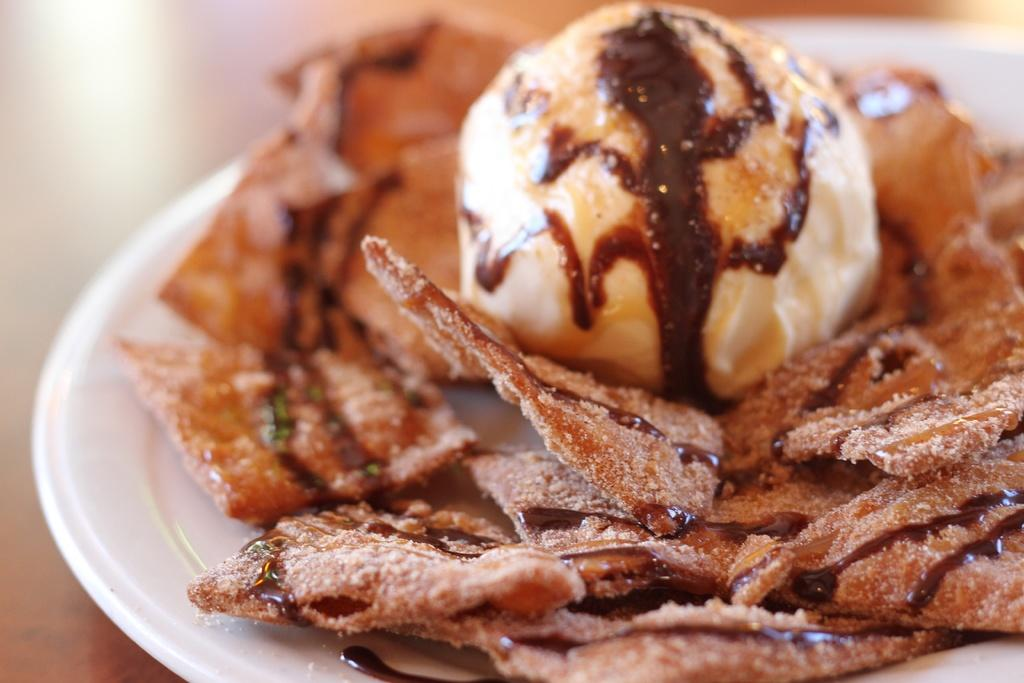What is on the plate that is visible in the image? There are food items on a plate in the image. Where is the plate located in the image? The plate is placed on a table in the image. What is the quiet substance that can be seen in the image? There is no mention of a quiet substance in the image; the image only features food items on a plate and a table. 